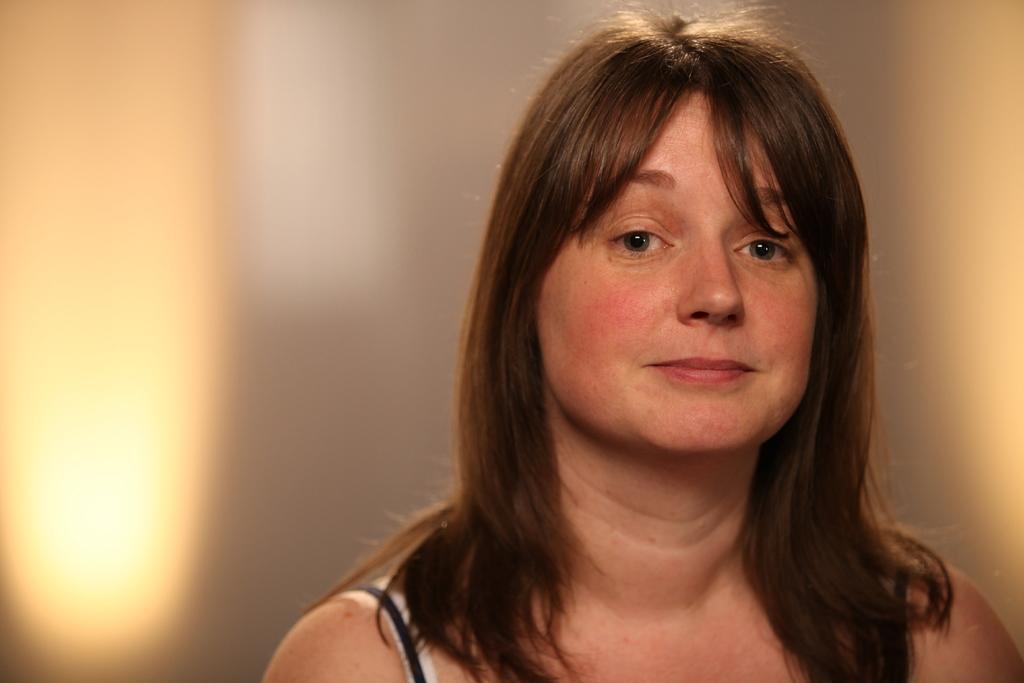What is the woman in the image doing? The woman in the image is looking at the camera and smiling. What can be observed about the background of the image? The background of the image is in white and yellow colors, and it is blurred. How many cakes are present in the image? There are no cakes visible in the image. What type of agreement is being made between the woman and the photographer in the image? There is no indication of an agreement being made in the image; the woman is simply looking at the camera and smiling. 